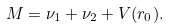<formula> <loc_0><loc_0><loc_500><loc_500>M = \nu _ { 1 } + \nu _ { 2 } + V ( r _ { 0 } ) .</formula> 